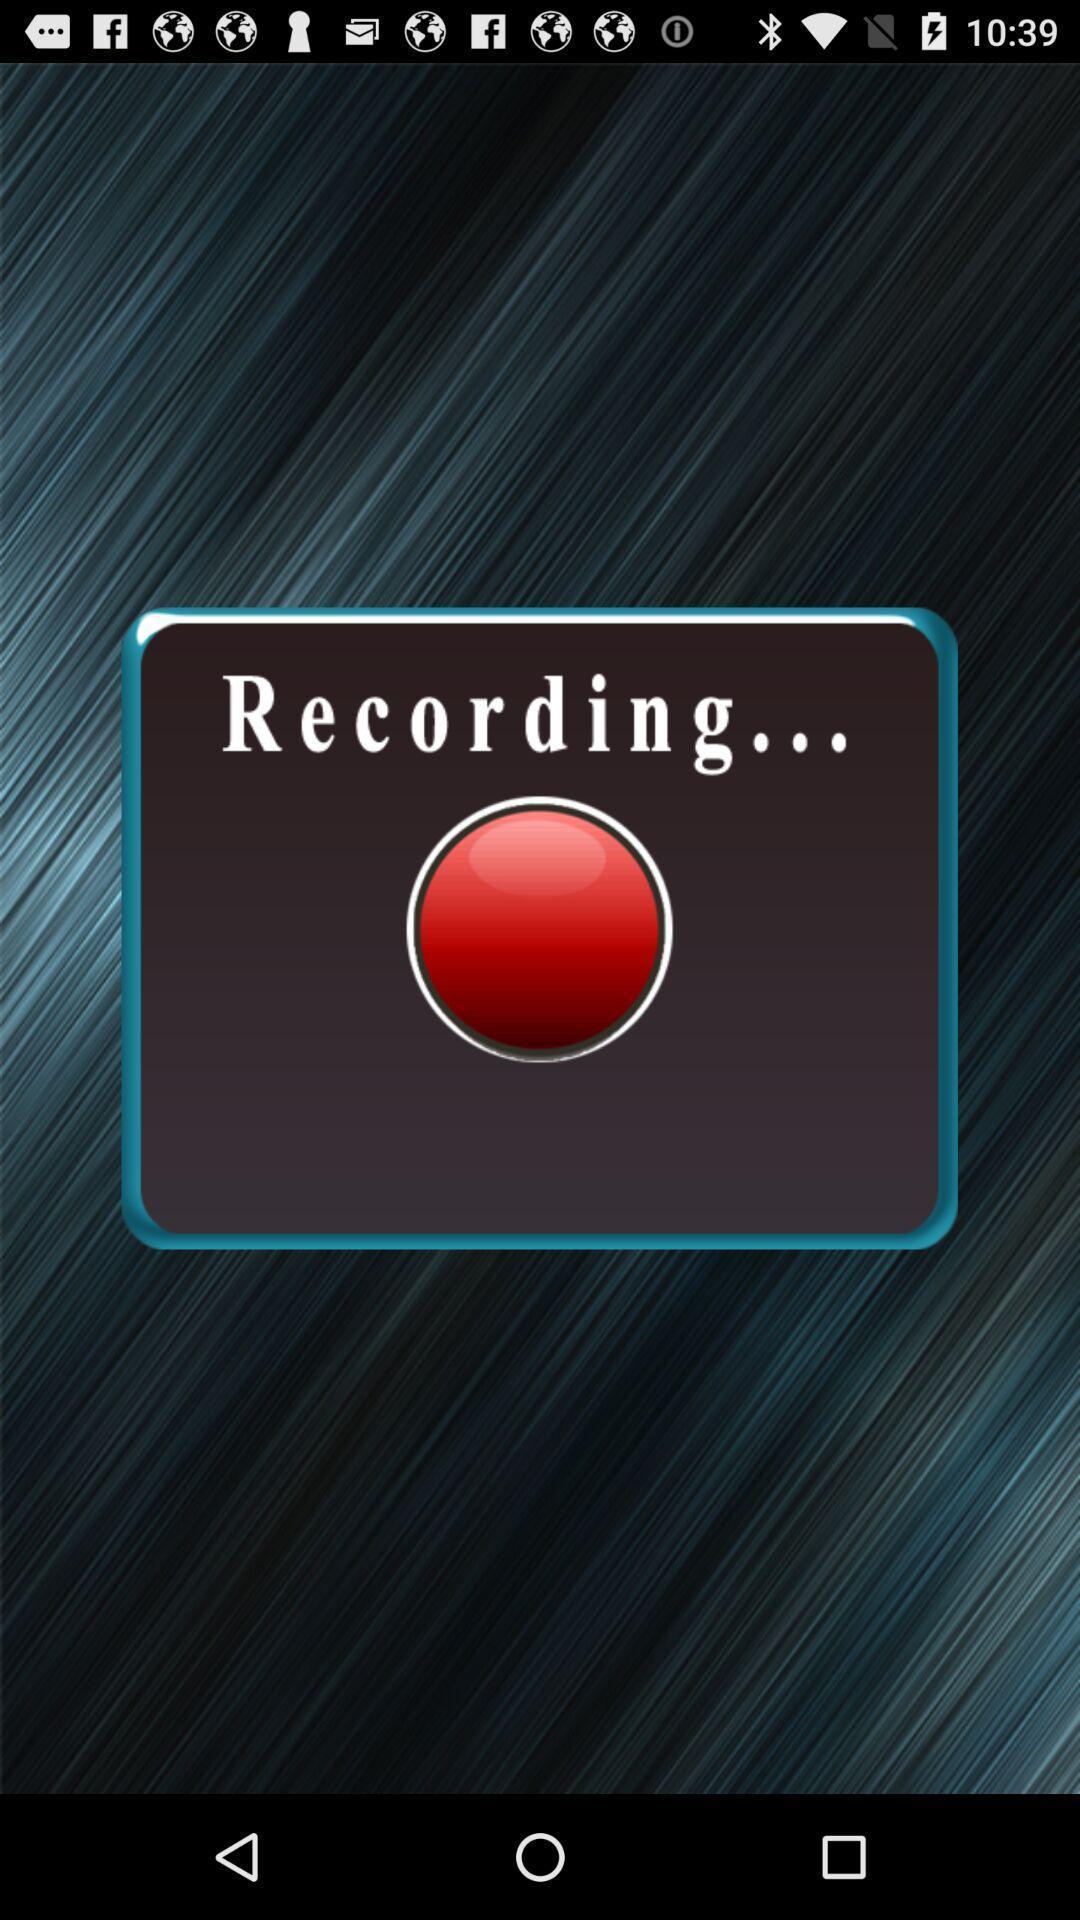Describe the visual elements of this screenshot. Screen displaying recording. 